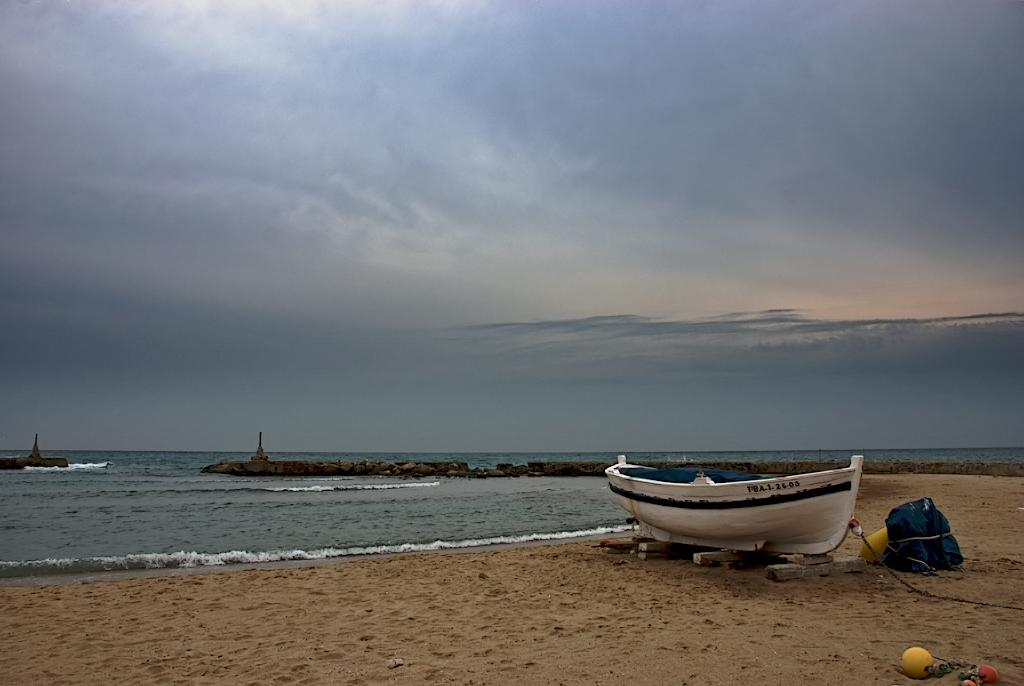What is the color of the boat in the image? The boat in the image is white. How is the boat positioned in the image? The boat is on wooden logs. What object is near the boat? There is a bag near the boat. What natural element is visible in the image? Water is visible in the image. What type of terrain is present in the image? Rocks are present in the image. What is visible above the boat and rocks? The sky is visible in the image. What type of stamp is on the boat's flag in the image? There is no flag or stamp present on the boat in the image. How many feet are visible in the image? There are no feet visible in the image. 